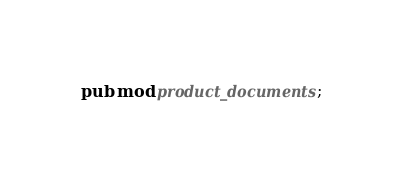Convert code to text. <code><loc_0><loc_0><loc_500><loc_500><_Rust_>pub mod product_documents;
</code> 